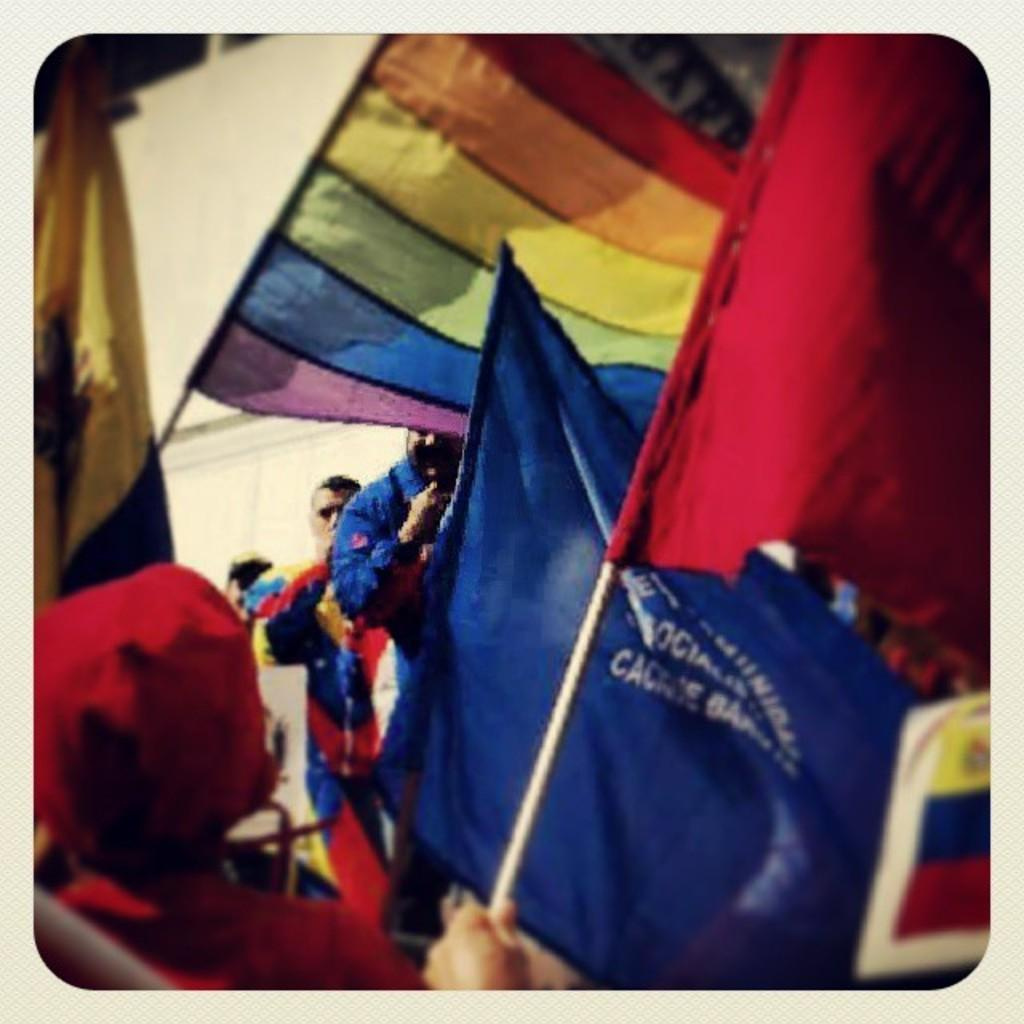What type of objects can be seen in the image? There are colorful flags in the image. Are there any people present in the image? Yes, there are people visible in the image. Can you describe the flags in more detail? At least one of the flags has writing on it. What type of club can be seen in the image? There is no club present in the image; it features colorful flags and people. Can you tell me how many times the person in the image requested something? There is no indication in the image that anyone made a request, so it cannot be determined from the picture. 